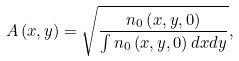Convert formula to latex. <formula><loc_0><loc_0><loc_500><loc_500>A \left ( x , y \right ) = \sqrt { \frac { n _ { 0 } \left ( x , y , 0 \right ) } { \int n _ { 0 } \left ( x , y , 0 \right ) d x d y } } ,</formula> 